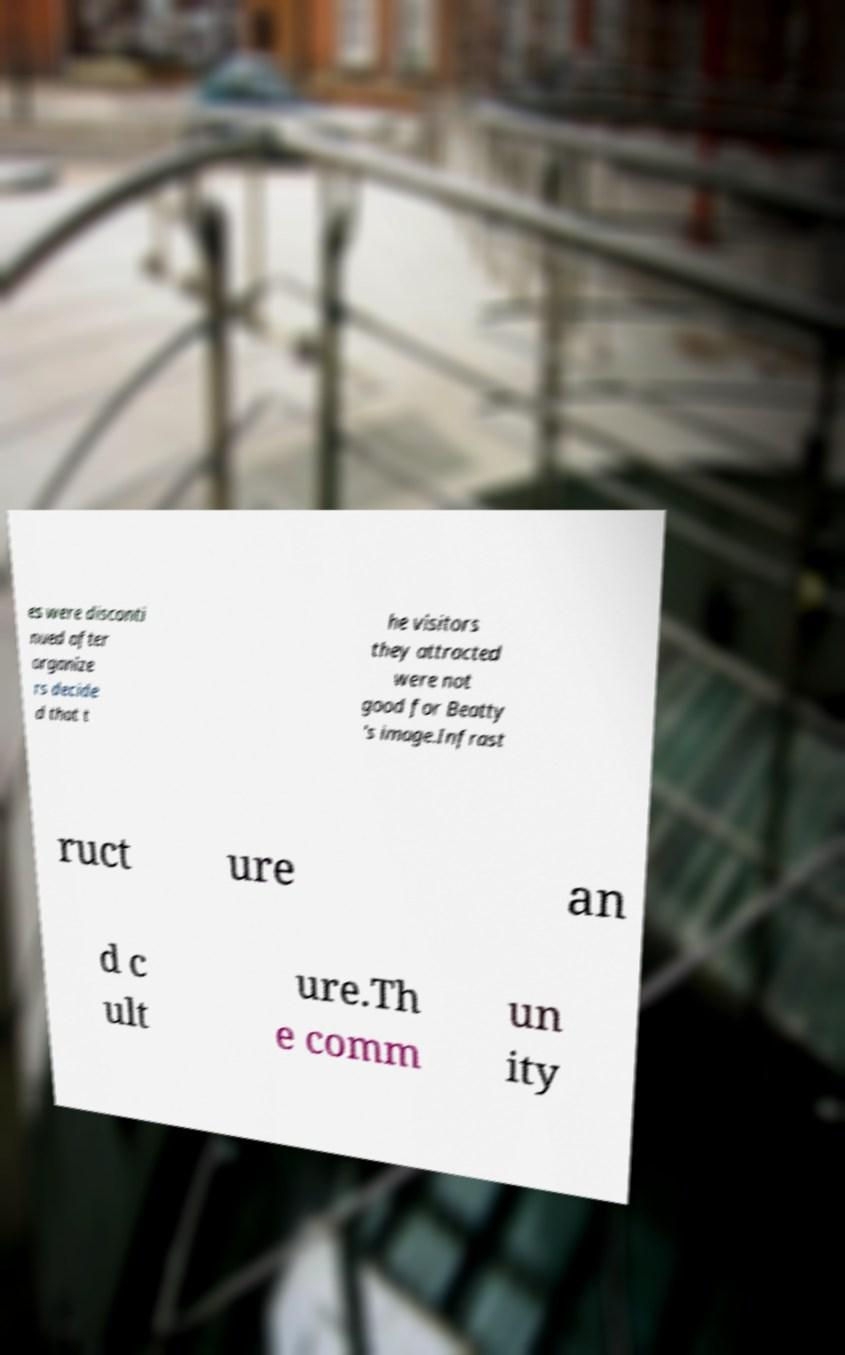Could you extract and type out the text from this image? es were disconti nued after organize rs decide d that t he visitors they attracted were not good for Beatty 's image.Infrast ruct ure an d c ult ure.Th e comm un ity 